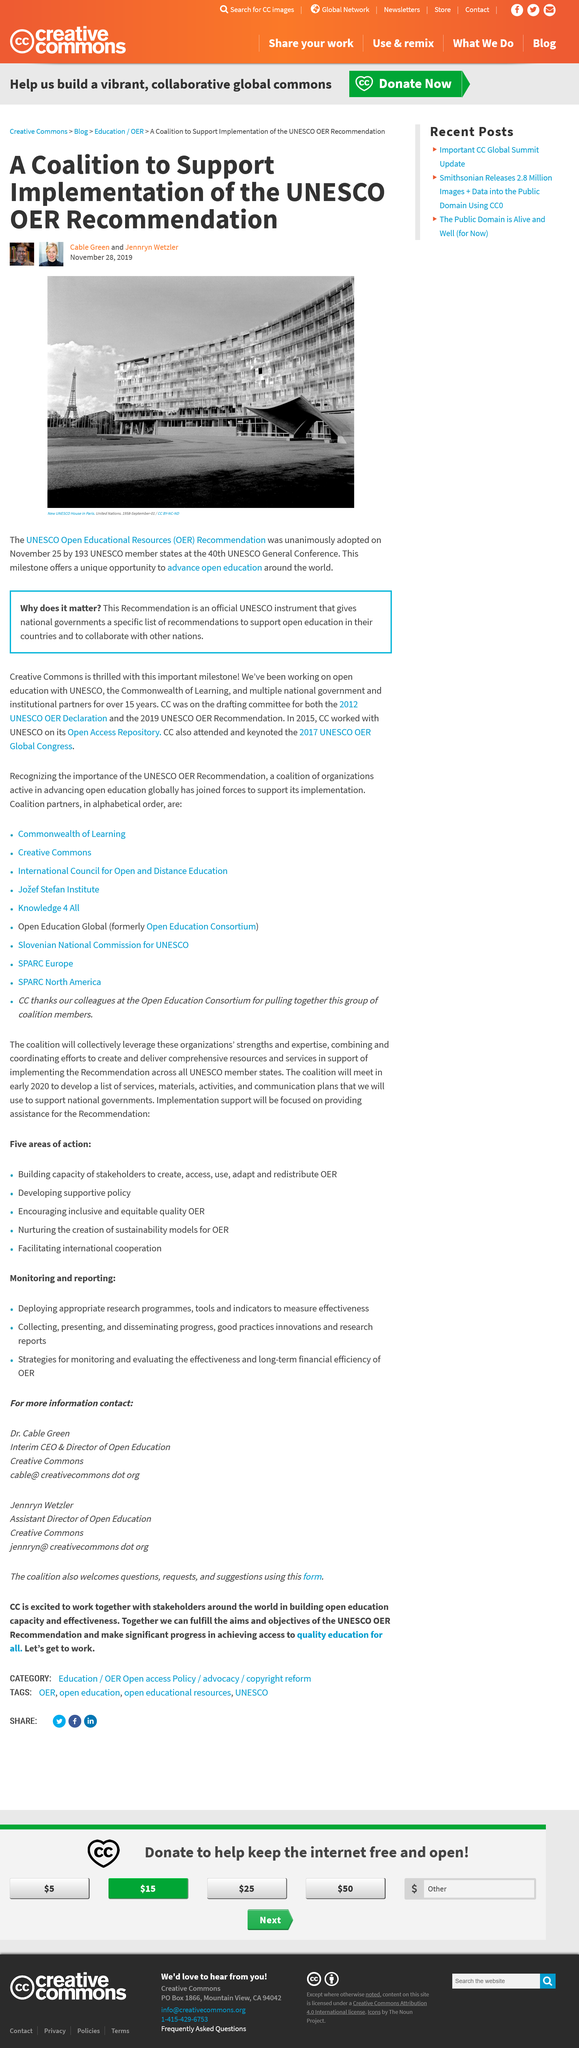Indicate a few pertinent items in this graphic. A total of 193 UNESCO member states have adopted the recommendation. In 2019, the recommendation was adopted. The photograph was taken in Paris, and the city in which it was taken is unknown. 